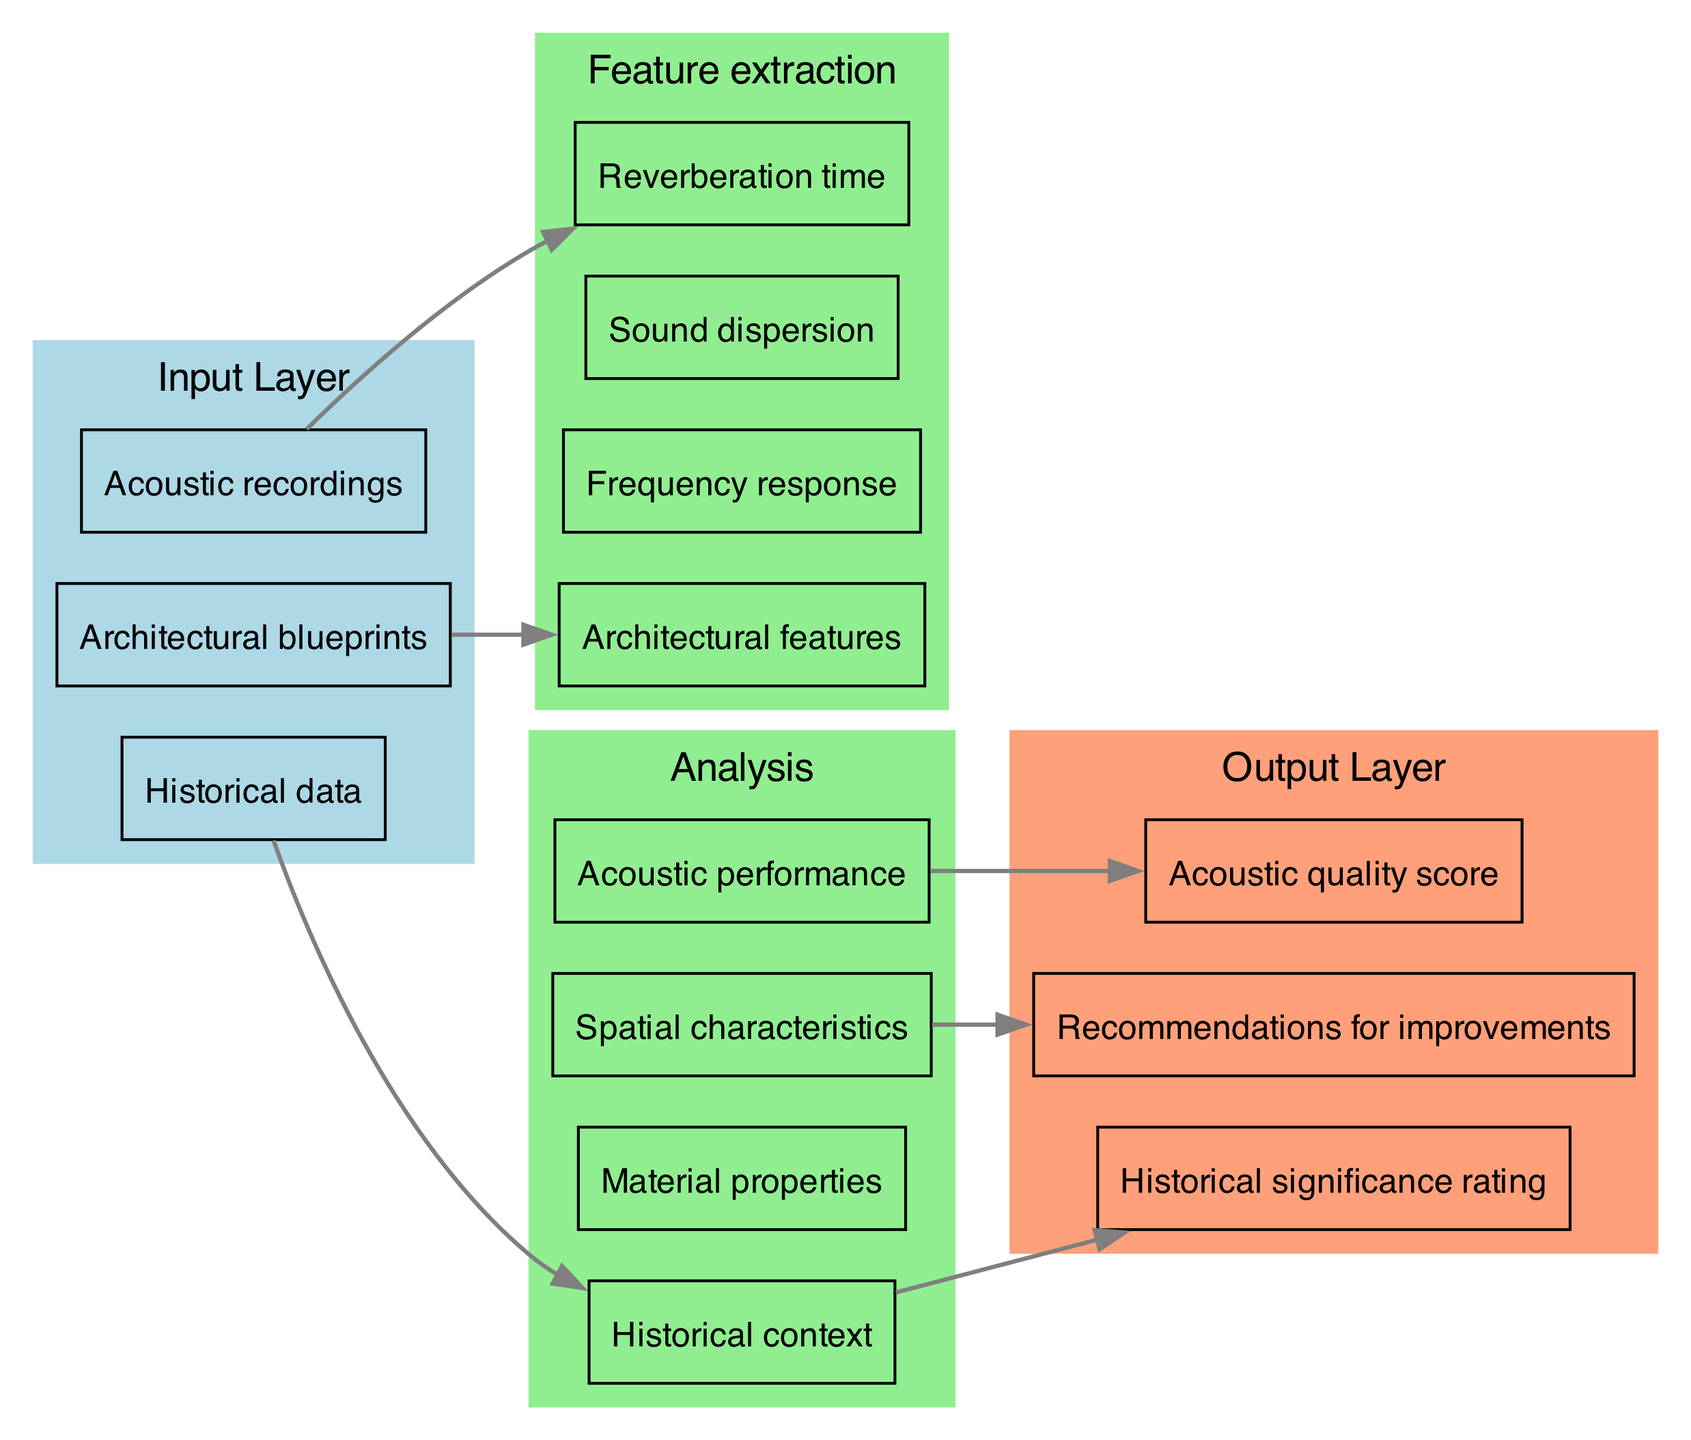What is the number of nodes in the output layer? The output layer contains three distinct nodes: "Acoustic quality score," "Recommendations for improvements," and "Historical significance rating." Thus, the count of nodes in this layer is three.
Answer: 3 Which input provides information about "Architectural features"? The input layer includes three elements, one of which is "Architectural blueprints." This input specifically relates to the node "Architectural features" in the first hidden layer, indicating that this is the source of information for that node.
Answer: Architectural blueprints What node is directly connected to "Reverberation time"? In the diagram, the input "Acoustic recordings" is shown as being directly connected to the node "Reverberation time." This depicts that acoustic recordings provide data that influences reverberation time calculations.
Answer: Acoustic recordings Which nodes are part of the "Analysis" hidden layer? The "Analysis" hidden layer contains four nodes: "Historical context," "Material properties," "Spatial characteristics," and "Acoustic performance." These nodes are crucial for analyzing various facets of acoustics and design in opera houses.
Answer: Historical context, Material properties, Spatial characteristics, Acoustic performance How many connections are there from the hidden layers to the output layer? There are three outgoing connections from the hidden layers to the output layer. The connections are: "Acoustic performance" to "Acoustic quality score," "Spatial characteristics" to "Recommendations for improvements," and "Historical context" to "Historical significance rating." Summarizing these connections gives us three.
Answer: 3 What is the purpose of the "Feature extraction" hidden layer? The "Feature extraction" hidden layer serves to process different attributes related to acoustics and design. Its nodes, including "Reverberation time," "Frequency response," "Sound dispersion," and "Architectural features," play specific roles in distilling important acoustic metrics from the provided inputs before further analysis.
Answer: To extract acoustic and architectural features Which input is associated with "Historical context"? The node "Historical context" in the hidden layer is connected to "Historical data" from the input layer. This indicates that the historical data is utilized to derive insights regarding the context of the opera house designs being analyzed.
Answer: Historical data What kind of score is produced in the output layer? The output layer produces an "Acoustic quality score," which quantifies the acoustic performance based on the analysis performed in the hidden layers. This score is essential for evaluating the effectiveness of the acoustic designs in opera houses.
Answer: Acoustic quality score 